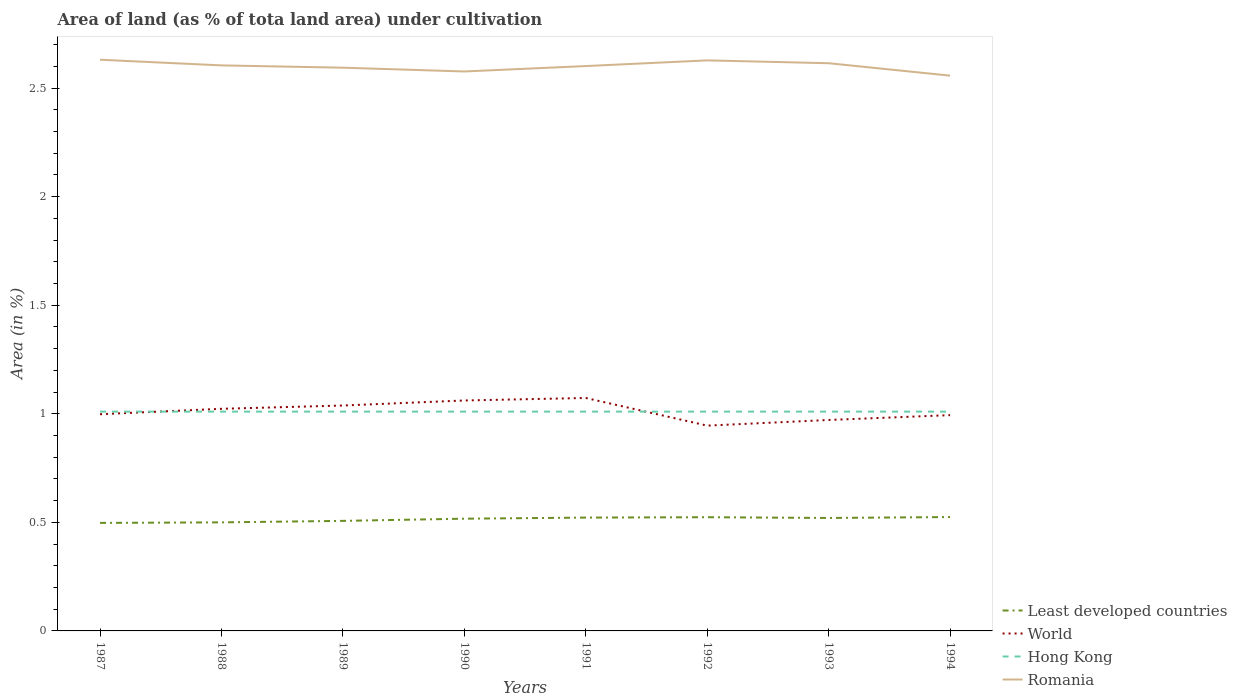Does the line corresponding to Least developed countries intersect with the line corresponding to Romania?
Provide a succinct answer. No. Across all years, what is the maximum percentage of land under cultivation in Least developed countries?
Offer a terse response. 0.5. What is the total percentage of land under cultivation in Least developed countries in the graph?
Provide a succinct answer. -0. What is the difference between the highest and the second highest percentage of land under cultivation in World?
Your response must be concise. 0.13. What is the difference between the highest and the lowest percentage of land under cultivation in Romania?
Your answer should be very brief. 5. What is the difference between two consecutive major ticks on the Y-axis?
Keep it short and to the point. 0.5. Does the graph contain grids?
Offer a very short reply. No. Where does the legend appear in the graph?
Offer a very short reply. Bottom right. How many legend labels are there?
Offer a very short reply. 4. What is the title of the graph?
Your answer should be compact. Area of land (as % of tota land area) under cultivation. What is the label or title of the Y-axis?
Ensure brevity in your answer.  Area (in %). What is the Area (in %) in Least developed countries in 1987?
Your response must be concise. 0.5. What is the Area (in %) of World in 1987?
Provide a short and direct response. 1. What is the Area (in %) of Hong Kong in 1987?
Offer a very short reply. 1.01. What is the Area (in %) in Romania in 1987?
Offer a very short reply. 2.63. What is the Area (in %) of Least developed countries in 1988?
Your answer should be very brief. 0.5. What is the Area (in %) of World in 1988?
Offer a very short reply. 1.02. What is the Area (in %) of Hong Kong in 1988?
Provide a short and direct response. 1.01. What is the Area (in %) of Romania in 1988?
Your answer should be compact. 2.6. What is the Area (in %) of Least developed countries in 1989?
Your answer should be compact. 0.51. What is the Area (in %) of World in 1989?
Provide a succinct answer. 1.04. What is the Area (in %) of Hong Kong in 1989?
Your response must be concise. 1.01. What is the Area (in %) in Romania in 1989?
Provide a short and direct response. 2.59. What is the Area (in %) in Least developed countries in 1990?
Your response must be concise. 0.52. What is the Area (in %) in World in 1990?
Your answer should be compact. 1.06. What is the Area (in %) in Hong Kong in 1990?
Make the answer very short. 1.01. What is the Area (in %) of Romania in 1990?
Ensure brevity in your answer.  2.58. What is the Area (in %) of Least developed countries in 1991?
Offer a terse response. 0.52. What is the Area (in %) of World in 1991?
Your answer should be very brief. 1.07. What is the Area (in %) in Hong Kong in 1991?
Ensure brevity in your answer.  1.01. What is the Area (in %) in Romania in 1991?
Provide a succinct answer. 2.6. What is the Area (in %) of Least developed countries in 1992?
Your response must be concise. 0.52. What is the Area (in %) of World in 1992?
Keep it short and to the point. 0.95. What is the Area (in %) of Hong Kong in 1992?
Your answer should be very brief. 1.01. What is the Area (in %) in Romania in 1992?
Your answer should be compact. 2.63. What is the Area (in %) in Least developed countries in 1993?
Offer a very short reply. 0.52. What is the Area (in %) in World in 1993?
Your response must be concise. 0.97. What is the Area (in %) in Hong Kong in 1993?
Offer a terse response. 1.01. What is the Area (in %) of Romania in 1993?
Your answer should be compact. 2.61. What is the Area (in %) in Least developed countries in 1994?
Ensure brevity in your answer.  0.52. What is the Area (in %) in World in 1994?
Make the answer very short. 0.99. What is the Area (in %) of Hong Kong in 1994?
Keep it short and to the point. 1.01. What is the Area (in %) of Romania in 1994?
Make the answer very short. 2.56. Across all years, what is the maximum Area (in %) of Least developed countries?
Provide a succinct answer. 0.52. Across all years, what is the maximum Area (in %) of World?
Ensure brevity in your answer.  1.07. Across all years, what is the maximum Area (in %) in Hong Kong?
Provide a succinct answer. 1.01. Across all years, what is the maximum Area (in %) of Romania?
Ensure brevity in your answer.  2.63. Across all years, what is the minimum Area (in %) of Least developed countries?
Your answer should be very brief. 0.5. Across all years, what is the minimum Area (in %) in World?
Provide a short and direct response. 0.95. Across all years, what is the minimum Area (in %) of Hong Kong?
Your response must be concise. 1.01. Across all years, what is the minimum Area (in %) in Romania?
Offer a very short reply. 2.56. What is the total Area (in %) of Least developed countries in the graph?
Offer a terse response. 4.11. What is the total Area (in %) in World in the graph?
Make the answer very short. 8.11. What is the total Area (in %) in Hong Kong in the graph?
Offer a very short reply. 8.08. What is the total Area (in %) of Romania in the graph?
Ensure brevity in your answer.  20.81. What is the difference between the Area (in %) of Least developed countries in 1987 and that in 1988?
Give a very brief answer. -0. What is the difference between the Area (in %) of World in 1987 and that in 1988?
Keep it short and to the point. -0.03. What is the difference between the Area (in %) of Hong Kong in 1987 and that in 1988?
Your response must be concise. 0. What is the difference between the Area (in %) in Romania in 1987 and that in 1988?
Your response must be concise. 0.03. What is the difference between the Area (in %) of Least developed countries in 1987 and that in 1989?
Give a very brief answer. -0.01. What is the difference between the Area (in %) of World in 1987 and that in 1989?
Your answer should be very brief. -0.04. What is the difference between the Area (in %) of Hong Kong in 1987 and that in 1989?
Your answer should be compact. 0. What is the difference between the Area (in %) in Romania in 1987 and that in 1989?
Ensure brevity in your answer.  0.04. What is the difference between the Area (in %) of Least developed countries in 1987 and that in 1990?
Keep it short and to the point. -0.02. What is the difference between the Area (in %) in World in 1987 and that in 1990?
Give a very brief answer. -0.06. What is the difference between the Area (in %) in Romania in 1987 and that in 1990?
Provide a succinct answer. 0.05. What is the difference between the Area (in %) in Least developed countries in 1987 and that in 1991?
Keep it short and to the point. -0.02. What is the difference between the Area (in %) in World in 1987 and that in 1991?
Ensure brevity in your answer.  -0.07. What is the difference between the Area (in %) of Romania in 1987 and that in 1991?
Give a very brief answer. 0.03. What is the difference between the Area (in %) of Least developed countries in 1987 and that in 1992?
Your answer should be very brief. -0.03. What is the difference between the Area (in %) in World in 1987 and that in 1992?
Make the answer very short. 0.05. What is the difference between the Area (in %) in Hong Kong in 1987 and that in 1992?
Provide a short and direct response. 0. What is the difference between the Area (in %) in Romania in 1987 and that in 1992?
Ensure brevity in your answer.  0. What is the difference between the Area (in %) of Least developed countries in 1987 and that in 1993?
Your answer should be compact. -0.02. What is the difference between the Area (in %) of World in 1987 and that in 1993?
Provide a short and direct response. 0.03. What is the difference between the Area (in %) of Hong Kong in 1987 and that in 1993?
Your answer should be compact. 0. What is the difference between the Area (in %) of Romania in 1987 and that in 1993?
Your response must be concise. 0.02. What is the difference between the Area (in %) in Least developed countries in 1987 and that in 1994?
Your answer should be compact. -0.03. What is the difference between the Area (in %) in World in 1987 and that in 1994?
Offer a terse response. 0. What is the difference between the Area (in %) in Romania in 1987 and that in 1994?
Your answer should be compact. 0.07. What is the difference between the Area (in %) of Least developed countries in 1988 and that in 1989?
Give a very brief answer. -0.01. What is the difference between the Area (in %) in World in 1988 and that in 1989?
Your response must be concise. -0.02. What is the difference between the Area (in %) in Romania in 1988 and that in 1989?
Your answer should be very brief. 0.01. What is the difference between the Area (in %) in Least developed countries in 1988 and that in 1990?
Offer a terse response. -0.02. What is the difference between the Area (in %) of World in 1988 and that in 1990?
Your answer should be compact. -0.04. What is the difference between the Area (in %) of Romania in 1988 and that in 1990?
Provide a succinct answer. 0.03. What is the difference between the Area (in %) in Least developed countries in 1988 and that in 1991?
Your response must be concise. -0.02. What is the difference between the Area (in %) in World in 1988 and that in 1991?
Provide a short and direct response. -0.05. What is the difference between the Area (in %) in Romania in 1988 and that in 1991?
Provide a short and direct response. 0. What is the difference between the Area (in %) in Least developed countries in 1988 and that in 1992?
Keep it short and to the point. -0.02. What is the difference between the Area (in %) of World in 1988 and that in 1992?
Make the answer very short. 0.08. What is the difference between the Area (in %) of Hong Kong in 1988 and that in 1992?
Provide a succinct answer. 0. What is the difference between the Area (in %) in Romania in 1988 and that in 1992?
Give a very brief answer. -0.02. What is the difference between the Area (in %) in Least developed countries in 1988 and that in 1993?
Your answer should be very brief. -0.02. What is the difference between the Area (in %) of World in 1988 and that in 1993?
Offer a terse response. 0.05. What is the difference between the Area (in %) in Hong Kong in 1988 and that in 1993?
Offer a terse response. 0. What is the difference between the Area (in %) of Romania in 1988 and that in 1993?
Give a very brief answer. -0.01. What is the difference between the Area (in %) in Least developed countries in 1988 and that in 1994?
Your answer should be very brief. -0.02. What is the difference between the Area (in %) in World in 1988 and that in 1994?
Offer a terse response. 0.03. What is the difference between the Area (in %) in Romania in 1988 and that in 1994?
Your response must be concise. 0.05. What is the difference between the Area (in %) in Least developed countries in 1989 and that in 1990?
Your response must be concise. -0.01. What is the difference between the Area (in %) of World in 1989 and that in 1990?
Your response must be concise. -0.02. What is the difference between the Area (in %) of Hong Kong in 1989 and that in 1990?
Ensure brevity in your answer.  0. What is the difference between the Area (in %) in Romania in 1989 and that in 1990?
Offer a very short reply. 0.02. What is the difference between the Area (in %) of Least developed countries in 1989 and that in 1991?
Your response must be concise. -0.02. What is the difference between the Area (in %) of World in 1989 and that in 1991?
Your response must be concise. -0.03. What is the difference between the Area (in %) of Romania in 1989 and that in 1991?
Your response must be concise. -0.01. What is the difference between the Area (in %) in Least developed countries in 1989 and that in 1992?
Offer a very short reply. -0.02. What is the difference between the Area (in %) in World in 1989 and that in 1992?
Your answer should be compact. 0.09. What is the difference between the Area (in %) of Hong Kong in 1989 and that in 1992?
Your answer should be very brief. 0. What is the difference between the Area (in %) in Romania in 1989 and that in 1992?
Keep it short and to the point. -0.03. What is the difference between the Area (in %) in Least developed countries in 1989 and that in 1993?
Offer a terse response. -0.01. What is the difference between the Area (in %) of World in 1989 and that in 1993?
Your response must be concise. 0.07. What is the difference between the Area (in %) in Romania in 1989 and that in 1993?
Your answer should be very brief. -0.02. What is the difference between the Area (in %) in Least developed countries in 1989 and that in 1994?
Ensure brevity in your answer.  -0.02. What is the difference between the Area (in %) in World in 1989 and that in 1994?
Provide a succinct answer. 0.04. What is the difference between the Area (in %) in Hong Kong in 1989 and that in 1994?
Your answer should be compact. 0. What is the difference between the Area (in %) in Romania in 1989 and that in 1994?
Your response must be concise. 0.04. What is the difference between the Area (in %) of Least developed countries in 1990 and that in 1991?
Your answer should be compact. -0.01. What is the difference between the Area (in %) in World in 1990 and that in 1991?
Give a very brief answer. -0.01. What is the difference between the Area (in %) of Hong Kong in 1990 and that in 1991?
Your answer should be very brief. 0. What is the difference between the Area (in %) in Romania in 1990 and that in 1991?
Your answer should be compact. -0.02. What is the difference between the Area (in %) in Least developed countries in 1990 and that in 1992?
Ensure brevity in your answer.  -0.01. What is the difference between the Area (in %) in World in 1990 and that in 1992?
Provide a short and direct response. 0.12. What is the difference between the Area (in %) of Hong Kong in 1990 and that in 1992?
Your answer should be very brief. 0. What is the difference between the Area (in %) of Romania in 1990 and that in 1992?
Make the answer very short. -0.05. What is the difference between the Area (in %) in Least developed countries in 1990 and that in 1993?
Offer a terse response. -0. What is the difference between the Area (in %) of World in 1990 and that in 1993?
Provide a succinct answer. 0.09. What is the difference between the Area (in %) of Romania in 1990 and that in 1993?
Keep it short and to the point. -0.04. What is the difference between the Area (in %) in Least developed countries in 1990 and that in 1994?
Provide a short and direct response. -0.01. What is the difference between the Area (in %) in World in 1990 and that in 1994?
Your answer should be very brief. 0.07. What is the difference between the Area (in %) of Romania in 1990 and that in 1994?
Your response must be concise. 0.02. What is the difference between the Area (in %) of Least developed countries in 1991 and that in 1992?
Make the answer very short. -0. What is the difference between the Area (in %) in World in 1991 and that in 1992?
Give a very brief answer. 0.13. What is the difference between the Area (in %) in Hong Kong in 1991 and that in 1992?
Your answer should be compact. 0. What is the difference between the Area (in %) of Romania in 1991 and that in 1992?
Your answer should be very brief. -0.03. What is the difference between the Area (in %) of Least developed countries in 1991 and that in 1993?
Make the answer very short. 0. What is the difference between the Area (in %) of World in 1991 and that in 1993?
Offer a terse response. 0.1. What is the difference between the Area (in %) of Hong Kong in 1991 and that in 1993?
Provide a short and direct response. 0. What is the difference between the Area (in %) of Romania in 1991 and that in 1993?
Provide a short and direct response. -0.01. What is the difference between the Area (in %) of Least developed countries in 1991 and that in 1994?
Offer a terse response. -0. What is the difference between the Area (in %) of World in 1991 and that in 1994?
Make the answer very short. 0.08. What is the difference between the Area (in %) in Hong Kong in 1991 and that in 1994?
Provide a short and direct response. 0. What is the difference between the Area (in %) in Romania in 1991 and that in 1994?
Provide a short and direct response. 0.04. What is the difference between the Area (in %) of Least developed countries in 1992 and that in 1993?
Provide a succinct answer. 0. What is the difference between the Area (in %) in World in 1992 and that in 1993?
Give a very brief answer. -0.03. What is the difference between the Area (in %) of Romania in 1992 and that in 1993?
Provide a succinct answer. 0.01. What is the difference between the Area (in %) of Least developed countries in 1992 and that in 1994?
Your response must be concise. -0. What is the difference between the Area (in %) of World in 1992 and that in 1994?
Your response must be concise. -0.05. What is the difference between the Area (in %) in Romania in 1992 and that in 1994?
Provide a short and direct response. 0.07. What is the difference between the Area (in %) in Least developed countries in 1993 and that in 1994?
Offer a very short reply. -0. What is the difference between the Area (in %) of World in 1993 and that in 1994?
Your answer should be compact. -0.02. What is the difference between the Area (in %) in Romania in 1993 and that in 1994?
Your answer should be very brief. 0.06. What is the difference between the Area (in %) in Least developed countries in 1987 and the Area (in %) in World in 1988?
Ensure brevity in your answer.  -0.53. What is the difference between the Area (in %) in Least developed countries in 1987 and the Area (in %) in Hong Kong in 1988?
Provide a succinct answer. -0.51. What is the difference between the Area (in %) of Least developed countries in 1987 and the Area (in %) of Romania in 1988?
Give a very brief answer. -2.11. What is the difference between the Area (in %) of World in 1987 and the Area (in %) of Hong Kong in 1988?
Keep it short and to the point. -0.01. What is the difference between the Area (in %) of World in 1987 and the Area (in %) of Romania in 1988?
Your answer should be very brief. -1.61. What is the difference between the Area (in %) of Hong Kong in 1987 and the Area (in %) of Romania in 1988?
Your answer should be very brief. -1.59. What is the difference between the Area (in %) of Least developed countries in 1987 and the Area (in %) of World in 1989?
Give a very brief answer. -0.54. What is the difference between the Area (in %) in Least developed countries in 1987 and the Area (in %) in Hong Kong in 1989?
Your response must be concise. -0.51. What is the difference between the Area (in %) of Least developed countries in 1987 and the Area (in %) of Romania in 1989?
Make the answer very short. -2.1. What is the difference between the Area (in %) of World in 1987 and the Area (in %) of Hong Kong in 1989?
Ensure brevity in your answer.  -0.01. What is the difference between the Area (in %) in World in 1987 and the Area (in %) in Romania in 1989?
Give a very brief answer. -1.6. What is the difference between the Area (in %) in Hong Kong in 1987 and the Area (in %) in Romania in 1989?
Provide a succinct answer. -1.58. What is the difference between the Area (in %) of Least developed countries in 1987 and the Area (in %) of World in 1990?
Offer a very short reply. -0.56. What is the difference between the Area (in %) of Least developed countries in 1987 and the Area (in %) of Hong Kong in 1990?
Your response must be concise. -0.51. What is the difference between the Area (in %) in Least developed countries in 1987 and the Area (in %) in Romania in 1990?
Provide a succinct answer. -2.08. What is the difference between the Area (in %) in World in 1987 and the Area (in %) in Hong Kong in 1990?
Offer a very short reply. -0.01. What is the difference between the Area (in %) in World in 1987 and the Area (in %) in Romania in 1990?
Keep it short and to the point. -1.58. What is the difference between the Area (in %) of Hong Kong in 1987 and the Area (in %) of Romania in 1990?
Provide a short and direct response. -1.57. What is the difference between the Area (in %) in Least developed countries in 1987 and the Area (in %) in World in 1991?
Offer a very short reply. -0.58. What is the difference between the Area (in %) in Least developed countries in 1987 and the Area (in %) in Hong Kong in 1991?
Give a very brief answer. -0.51. What is the difference between the Area (in %) in Least developed countries in 1987 and the Area (in %) in Romania in 1991?
Your answer should be very brief. -2.1. What is the difference between the Area (in %) in World in 1987 and the Area (in %) in Hong Kong in 1991?
Give a very brief answer. -0.01. What is the difference between the Area (in %) of World in 1987 and the Area (in %) of Romania in 1991?
Offer a terse response. -1.6. What is the difference between the Area (in %) in Hong Kong in 1987 and the Area (in %) in Romania in 1991?
Offer a very short reply. -1.59. What is the difference between the Area (in %) in Least developed countries in 1987 and the Area (in %) in World in 1992?
Provide a succinct answer. -0.45. What is the difference between the Area (in %) of Least developed countries in 1987 and the Area (in %) of Hong Kong in 1992?
Offer a terse response. -0.51. What is the difference between the Area (in %) of Least developed countries in 1987 and the Area (in %) of Romania in 1992?
Your response must be concise. -2.13. What is the difference between the Area (in %) of World in 1987 and the Area (in %) of Hong Kong in 1992?
Provide a succinct answer. -0.01. What is the difference between the Area (in %) in World in 1987 and the Area (in %) in Romania in 1992?
Ensure brevity in your answer.  -1.63. What is the difference between the Area (in %) in Hong Kong in 1987 and the Area (in %) in Romania in 1992?
Offer a very short reply. -1.62. What is the difference between the Area (in %) in Least developed countries in 1987 and the Area (in %) in World in 1993?
Offer a very short reply. -0.47. What is the difference between the Area (in %) of Least developed countries in 1987 and the Area (in %) of Hong Kong in 1993?
Your response must be concise. -0.51. What is the difference between the Area (in %) in Least developed countries in 1987 and the Area (in %) in Romania in 1993?
Provide a short and direct response. -2.12. What is the difference between the Area (in %) in World in 1987 and the Area (in %) in Hong Kong in 1993?
Ensure brevity in your answer.  -0.01. What is the difference between the Area (in %) of World in 1987 and the Area (in %) of Romania in 1993?
Give a very brief answer. -1.62. What is the difference between the Area (in %) of Hong Kong in 1987 and the Area (in %) of Romania in 1993?
Ensure brevity in your answer.  -1.6. What is the difference between the Area (in %) in Least developed countries in 1987 and the Area (in %) in World in 1994?
Your response must be concise. -0.5. What is the difference between the Area (in %) in Least developed countries in 1987 and the Area (in %) in Hong Kong in 1994?
Ensure brevity in your answer.  -0.51. What is the difference between the Area (in %) of Least developed countries in 1987 and the Area (in %) of Romania in 1994?
Ensure brevity in your answer.  -2.06. What is the difference between the Area (in %) in World in 1987 and the Area (in %) in Hong Kong in 1994?
Offer a very short reply. -0.01. What is the difference between the Area (in %) of World in 1987 and the Area (in %) of Romania in 1994?
Your response must be concise. -1.56. What is the difference between the Area (in %) of Hong Kong in 1987 and the Area (in %) of Romania in 1994?
Give a very brief answer. -1.55. What is the difference between the Area (in %) of Least developed countries in 1988 and the Area (in %) of World in 1989?
Provide a short and direct response. -0.54. What is the difference between the Area (in %) in Least developed countries in 1988 and the Area (in %) in Hong Kong in 1989?
Provide a succinct answer. -0.51. What is the difference between the Area (in %) in Least developed countries in 1988 and the Area (in %) in Romania in 1989?
Make the answer very short. -2.09. What is the difference between the Area (in %) of World in 1988 and the Area (in %) of Hong Kong in 1989?
Provide a short and direct response. 0.01. What is the difference between the Area (in %) in World in 1988 and the Area (in %) in Romania in 1989?
Make the answer very short. -1.57. What is the difference between the Area (in %) of Hong Kong in 1988 and the Area (in %) of Romania in 1989?
Your answer should be compact. -1.58. What is the difference between the Area (in %) of Least developed countries in 1988 and the Area (in %) of World in 1990?
Your answer should be compact. -0.56. What is the difference between the Area (in %) of Least developed countries in 1988 and the Area (in %) of Hong Kong in 1990?
Offer a terse response. -0.51. What is the difference between the Area (in %) of Least developed countries in 1988 and the Area (in %) of Romania in 1990?
Keep it short and to the point. -2.08. What is the difference between the Area (in %) in World in 1988 and the Area (in %) in Hong Kong in 1990?
Provide a succinct answer. 0.01. What is the difference between the Area (in %) in World in 1988 and the Area (in %) in Romania in 1990?
Make the answer very short. -1.55. What is the difference between the Area (in %) of Hong Kong in 1988 and the Area (in %) of Romania in 1990?
Your response must be concise. -1.57. What is the difference between the Area (in %) of Least developed countries in 1988 and the Area (in %) of World in 1991?
Make the answer very short. -0.57. What is the difference between the Area (in %) in Least developed countries in 1988 and the Area (in %) in Hong Kong in 1991?
Give a very brief answer. -0.51. What is the difference between the Area (in %) in Least developed countries in 1988 and the Area (in %) in Romania in 1991?
Keep it short and to the point. -2.1. What is the difference between the Area (in %) in World in 1988 and the Area (in %) in Hong Kong in 1991?
Your response must be concise. 0.01. What is the difference between the Area (in %) of World in 1988 and the Area (in %) of Romania in 1991?
Provide a short and direct response. -1.58. What is the difference between the Area (in %) of Hong Kong in 1988 and the Area (in %) of Romania in 1991?
Your answer should be very brief. -1.59. What is the difference between the Area (in %) of Least developed countries in 1988 and the Area (in %) of World in 1992?
Provide a short and direct response. -0.45. What is the difference between the Area (in %) of Least developed countries in 1988 and the Area (in %) of Hong Kong in 1992?
Offer a very short reply. -0.51. What is the difference between the Area (in %) in Least developed countries in 1988 and the Area (in %) in Romania in 1992?
Offer a very short reply. -2.13. What is the difference between the Area (in %) in World in 1988 and the Area (in %) in Hong Kong in 1992?
Your answer should be very brief. 0.01. What is the difference between the Area (in %) in World in 1988 and the Area (in %) in Romania in 1992?
Your answer should be very brief. -1.6. What is the difference between the Area (in %) of Hong Kong in 1988 and the Area (in %) of Romania in 1992?
Keep it short and to the point. -1.62. What is the difference between the Area (in %) in Least developed countries in 1988 and the Area (in %) in World in 1993?
Offer a terse response. -0.47. What is the difference between the Area (in %) of Least developed countries in 1988 and the Area (in %) of Hong Kong in 1993?
Make the answer very short. -0.51. What is the difference between the Area (in %) in Least developed countries in 1988 and the Area (in %) in Romania in 1993?
Make the answer very short. -2.11. What is the difference between the Area (in %) in World in 1988 and the Area (in %) in Hong Kong in 1993?
Your answer should be compact. 0.01. What is the difference between the Area (in %) of World in 1988 and the Area (in %) of Romania in 1993?
Offer a terse response. -1.59. What is the difference between the Area (in %) in Hong Kong in 1988 and the Area (in %) in Romania in 1993?
Provide a succinct answer. -1.6. What is the difference between the Area (in %) of Least developed countries in 1988 and the Area (in %) of World in 1994?
Keep it short and to the point. -0.49. What is the difference between the Area (in %) in Least developed countries in 1988 and the Area (in %) in Hong Kong in 1994?
Your answer should be compact. -0.51. What is the difference between the Area (in %) of Least developed countries in 1988 and the Area (in %) of Romania in 1994?
Provide a succinct answer. -2.06. What is the difference between the Area (in %) in World in 1988 and the Area (in %) in Hong Kong in 1994?
Your answer should be very brief. 0.01. What is the difference between the Area (in %) of World in 1988 and the Area (in %) of Romania in 1994?
Your response must be concise. -1.53. What is the difference between the Area (in %) in Hong Kong in 1988 and the Area (in %) in Romania in 1994?
Give a very brief answer. -1.55. What is the difference between the Area (in %) in Least developed countries in 1989 and the Area (in %) in World in 1990?
Your response must be concise. -0.55. What is the difference between the Area (in %) in Least developed countries in 1989 and the Area (in %) in Hong Kong in 1990?
Provide a short and direct response. -0.5. What is the difference between the Area (in %) in Least developed countries in 1989 and the Area (in %) in Romania in 1990?
Keep it short and to the point. -2.07. What is the difference between the Area (in %) of World in 1989 and the Area (in %) of Hong Kong in 1990?
Provide a short and direct response. 0.03. What is the difference between the Area (in %) in World in 1989 and the Area (in %) in Romania in 1990?
Provide a succinct answer. -1.54. What is the difference between the Area (in %) of Hong Kong in 1989 and the Area (in %) of Romania in 1990?
Make the answer very short. -1.57. What is the difference between the Area (in %) of Least developed countries in 1989 and the Area (in %) of World in 1991?
Give a very brief answer. -0.57. What is the difference between the Area (in %) of Least developed countries in 1989 and the Area (in %) of Hong Kong in 1991?
Ensure brevity in your answer.  -0.5. What is the difference between the Area (in %) in Least developed countries in 1989 and the Area (in %) in Romania in 1991?
Ensure brevity in your answer.  -2.09. What is the difference between the Area (in %) in World in 1989 and the Area (in %) in Hong Kong in 1991?
Your response must be concise. 0.03. What is the difference between the Area (in %) of World in 1989 and the Area (in %) of Romania in 1991?
Make the answer very short. -1.56. What is the difference between the Area (in %) in Hong Kong in 1989 and the Area (in %) in Romania in 1991?
Make the answer very short. -1.59. What is the difference between the Area (in %) in Least developed countries in 1989 and the Area (in %) in World in 1992?
Provide a succinct answer. -0.44. What is the difference between the Area (in %) of Least developed countries in 1989 and the Area (in %) of Hong Kong in 1992?
Offer a terse response. -0.5. What is the difference between the Area (in %) in Least developed countries in 1989 and the Area (in %) in Romania in 1992?
Provide a succinct answer. -2.12. What is the difference between the Area (in %) of World in 1989 and the Area (in %) of Hong Kong in 1992?
Offer a terse response. 0.03. What is the difference between the Area (in %) of World in 1989 and the Area (in %) of Romania in 1992?
Make the answer very short. -1.59. What is the difference between the Area (in %) in Hong Kong in 1989 and the Area (in %) in Romania in 1992?
Your answer should be compact. -1.62. What is the difference between the Area (in %) of Least developed countries in 1989 and the Area (in %) of World in 1993?
Offer a very short reply. -0.46. What is the difference between the Area (in %) in Least developed countries in 1989 and the Area (in %) in Hong Kong in 1993?
Provide a succinct answer. -0.5. What is the difference between the Area (in %) of Least developed countries in 1989 and the Area (in %) of Romania in 1993?
Your answer should be very brief. -2.11. What is the difference between the Area (in %) in World in 1989 and the Area (in %) in Hong Kong in 1993?
Provide a short and direct response. 0.03. What is the difference between the Area (in %) of World in 1989 and the Area (in %) of Romania in 1993?
Offer a terse response. -1.58. What is the difference between the Area (in %) of Hong Kong in 1989 and the Area (in %) of Romania in 1993?
Your response must be concise. -1.6. What is the difference between the Area (in %) in Least developed countries in 1989 and the Area (in %) in World in 1994?
Make the answer very short. -0.49. What is the difference between the Area (in %) in Least developed countries in 1989 and the Area (in %) in Hong Kong in 1994?
Ensure brevity in your answer.  -0.5. What is the difference between the Area (in %) of Least developed countries in 1989 and the Area (in %) of Romania in 1994?
Provide a short and direct response. -2.05. What is the difference between the Area (in %) of World in 1989 and the Area (in %) of Hong Kong in 1994?
Give a very brief answer. 0.03. What is the difference between the Area (in %) in World in 1989 and the Area (in %) in Romania in 1994?
Offer a terse response. -1.52. What is the difference between the Area (in %) in Hong Kong in 1989 and the Area (in %) in Romania in 1994?
Provide a short and direct response. -1.55. What is the difference between the Area (in %) of Least developed countries in 1990 and the Area (in %) of World in 1991?
Provide a short and direct response. -0.56. What is the difference between the Area (in %) of Least developed countries in 1990 and the Area (in %) of Hong Kong in 1991?
Your answer should be very brief. -0.49. What is the difference between the Area (in %) in Least developed countries in 1990 and the Area (in %) in Romania in 1991?
Your answer should be very brief. -2.08. What is the difference between the Area (in %) of World in 1990 and the Area (in %) of Hong Kong in 1991?
Provide a short and direct response. 0.05. What is the difference between the Area (in %) in World in 1990 and the Area (in %) in Romania in 1991?
Give a very brief answer. -1.54. What is the difference between the Area (in %) of Hong Kong in 1990 and the Area (in %) of Romania in 1991?
Offer a very short reply. -1.59. What is the difference between the Area (in %) in Least developed countries in 1990 and the Area (in %) in World in 1992?
Make the answer very short. -0.43. What is the difference between the Area (in %) of Least developed countries in 1990 and the Area (in %) of Hong Kong in 1992?
Make the answer very short. -0.49. What is the difference between the Area (in %) in Least developed countries in 1990 and the Area (in %) in Romania in 1992?
Offer a terse response. -2.11. What is the difference between the Area (in %) of World in 1990 and the Area (in %) of Hong Kong in 1992?
Ensure brevity in your answer.  0.05. What is the difference between the Area (in %) of World in 1990 and the Area (in %) of Romania in 1992?
Your answer should be very brief. -1.57. What is the difference between the Area (in %) in Hong Kong in 1990 and the Area (in %) in Romania in 1992?
Provide a short and direct response. -1.62. What is the difference between the Area (in %) in Least developed countries in 1990 and the Area (in %) in World in 1993?
Make the answer very short. -0.45. What is the difference between the Area (in %) in Least developed countries in 1990 and the Area (in %) in Hong Kong in 1993?
Keep it short and to the point. -0.49. What is the difference between the Area (in %) of Least developed countries in 1990 and the Area (in %) of Romania in 1993?
Keep it short and to the point. -2.1. What is the difference between the Area (in %) in World in 1990 and the Area (in %) in Hong Kong in 1993?
Your answer should be very brief. 0.05. What is the difference between the Area (in %) of World in 1990 and the Area (in %) of Romania in 1993?
Provide a short and direct response. -1.55. What is the difference between the Area (in %) of Hong Kong in 1990 and the Area (in %) of Romania in 1993?
Your answer should be very brief. -1.6. What is the difference between the Area (in %) in Least developed countries in 1990 and the Area (in %) in World in 1994?
Offer a terse response. -0.48. What is the difference between the Area (in %) in Least developed countries in 1990 and the Area (in %) in Hong Kong in 1994?
Keep it short and to the point. -0.49. What is the difference between the Area (in %) of Least developed countries in 1990 and the Area (in %) of Romania in 1994?
Offer a very short reply. -2.04. What is the difference between the Area (in %) in World in 1990 and the Area (in %) in Hong Kong in 1994?
Make the answer very short. 0.05. What is the difference between the Area (in %) in World in 1990 and the Area (in %) in Romania in 1994?
Provide a short and direct response. -1.5. What is the difference between the Area (in %) of Hong Kong in 1990 and the Area (in %) of Romania in 1994?
Your response must be concise. -1.55. What is the difference between the Area (in %) in Least developed countries in 1991 and the Area (in %) in World in 1992?
Offer a terse response. -0.42. What is the difference between the Area (in %) of Least developed countries in 1991 and the Area (in %) of Hong Kong in 1992?
Ensure brevity in your answer.  -0.49. What is the difference between the Area (in %) in Least developed countries in 1991 and the Area (in %) in Romania in 1992?
Offer a terse response. -2.11. What is the difference between the Area (in %) of World in 1991 and the Area (in %) of Hong Kong in 1992?
Your answer should be very brief. 0.06. What is the difference between the Area (in %) of World in 1991 and the Area (in %) of Romania in 1992?
Your answer should be compact. -1.55. What is the difference between the Area (in %) in Hong Kong in 1991 and the Area (in %) in Romania in 1992?
Make the answer very short. -1.62. What is the difference between the Area (in %) in Least developed countries in 1991 and the Area (in %) in World in 1993?
Make the answer very short. -0.45. What is the difference between the Area (in %) in Least developed countries in 1991 and the Area (in %) in Hong Kong in 1993?
Keep it short and to the point. -0.49. What is the difference between the Area (in %) in Least developed countries in 1991 and the Area (in %) in Romania in 1993?
Your answer should be compact. -2.09. What is the difference between the Area (in %) in World in 1991 and the Area (in %) in Hong Kong in 1993?
Offer a very short reply. 0.06. What is the difference between the Area (in %) in World in 1991 and the Area (in %) in Romania in 1993?
Your answer should be very brief. -1.54. What is the difference between the Area (in %) of Hong Kong in 1991 and the Area (in %) of Romania in 1993?
Provide a succinct answer. -1.6. What is the difference between the Area (in %) of Least developed countries in 1991 and the Area (in %) of World in 1994?
Your answer should be compact. -0.47. What is the difference between the Area (in %) of Least developed countries in 1991 and the Area (in %) of Hong Kong in 1994?
Ensure brevity in your answer.  -0.49. What is the difference between the Area (in %) of Least developed countries in 1991 and the Area (in %) of Romania in 1994?
Give a very brief answer. -2.04. What is the difference between the Area (in %) of World in 1991 and the Area (in %) of Hong Kong in 1994?
Ensure brevity in your answer.  0.06. What is the difference between the Area (in %) in World in 1991 and the Area (in %) in Romania in 1994?
Give a very brief answer. -1.48. What is the difference between the Area (in %) in Hong Kong in 1991 and the Area (in %) in Romania in 1994?
Offer a very short reply. -1.55. What is the difference between the Area (in %) of Least developed countries in 1992 and the Area (in %) of World in 1993?
Ensure brevity in your answer.  -0.45. What is the difference between the Area (in %) in Least developed countries in 1992 and the Area (in %) in Hong Kong in 1993?
Ensure brevity in your answer.  -0.49. What is the difference between the Area (in %) in Least developed countries in 1992 and the Area (in %) in Romania in 1993?
Your response must be concise. -2.09. What is the difference between the Area (in %) of World in 1992 and the Area (in %) of Hong Kong in 1993?
Your answer should be compact. -0.06. What is the difference between the Area (in %) in World in 1992 and the Area (in %) in Romania in 1993?
Give a very brief answer. -1.67. What is the difference between the Area (in %) in Hong Kong in 1992 and the Area (in %) in Romania in 1993?
Your answer should be compact. -1.6. What is the difference between the Area (in %) of Least developed countries in 1992 and the Area (in %) of World in 1994?
Ensure brevity in your answer.  -0.47. What is the difference between the Area (in %) of Least developed countries in 1992 and the Area (in %) of Hong Kong in 1994?
Your response must be concise. -0.49. What is the difference between the Area (in %) of Least developed countries in 1992 and the Area (in %) of Romania in 1994?
Make the answer very short. -2.03. What is the difference between the Area (in %) in World in 1992 and the Area (in %) in Hong Kong in 1994?
Your answer should be compact. -0.06. What is the difference between the Area (in %) in World in 1992 and the Area (in %) in Romania in 1994?
Offer a terse response. -1.61. What is the difference between the Area (in %) of Hong Kong in 1992 and the Area (in %) of Romania in 1994?
Offer a terse response. -1.55. What is the difference between the Area (in %) of Least developed countries in 1993 and the Area (in %) of World in 1994?
Ensure brevity in your answer.  -0.47. What is the difference between the Area (in %) in Least developed countries in 1993 and the Area (in %) in Hong Kong in 1994?
Offer a terse response. -0.49. What is the difference between the Area (in %) in Least developed countries in 1993 and the Area (in %) in Romania in 1994?
Make the answer very short. -2.04. What is the difference between the Area (in %) in World in 1993 and the Area (in %) in Hong Kong in 1994?
Your answer should be very brief. -0.04. What is the difference between the Area (in %) of World in 1993 and the Area (in %) of Romania in 1994?
Ensure brevity in your answer.  -1.59. What is the difference between the Area (in %) of Hong Kong in 1993 and the Area (in %) of Romania in 1994?
Offer a terse response. -1.55. What is the average Area (in %) of Least developed countries per year?
Your answer should be compact. 0.51. What is the average Area (in %) of World per year?
Offer a terse response. 1.01. What is the average Area (in %) in Hong Kong per year?
Your answer should be very brief. 1.01. What is the average Area (in %) of Romania per year?
Keep it short and to the point. 2.6. In the year 1987, what is the difference between the Area (in %) of Least developed countries and Area (in %) of World?
Ensure brevity in your answer.  -0.5. In the year 1987, what is the difference between the Area (in %) of Least developed countries and Area (in %) of Hong Kong?
Your response must be concise. -0.51. In the year 1987, what is the difference between the Area (in %) of Least developed countries and Area (in %) of Romania?
Give a very brief answer. -2.13. In the year 1987, what is the difference between the Area (in %) in World and Area (in %) in Hong Kong?
Give a very brief answer. -0.01. In the year 1987, what is the difference between the Area (in %) of World and Area (in %) of Romania?
Your response must be concise. -1.63. In the year 1987, what is the difference between the Area (in %) in Hong Kong and Area (in %) in Romania?
Provide a succinct answer. -1.62. In the year 1988, what is the difference between the Area (in %) in Least developed countries and Area (in %) in World?
Offer a terse response. -0.52. In the year 1988, what is the difference between the Area (in %) of Least developed countries and Area (in %) of Hong Kong?
Provide a short and direct response. -0.51. In the year 1988, what is the difference between the Area (in %) in Least developed countries and Area (in %) in Romania?
Make the answer very short. -2.1. In the year 1988, what is the difference between the Area (in %) of World and Area (in %) of Hong Kong?
Keep it short and to the point. 0.01. In the year 1988, what is the difference between the Area (in %) in World and Area (in %) in Romania?
Your answer should be compact. -1.58. In the year 1988, what is the difference between the Area (in %) of Hong Kong and Area (in %) of Romania?
Your answer should be compact. -1.59. In the year 1989, what is the difference between the Area (in %) in Least developed countries and Area (in %) in World?
Your answer should be very brief. -0.53. In the year 1989, what is the difference between the Area (in %) in Least developed countries and Area (in %) in Hong Kong?
Make the answer very short. -0.5. In the year 1989, what is the difference between the Area (in %) of Least developed countries and Area (in %) of Romania?
Offer a terse response. -2.09. In the year 1989, what is the difference between the Area (in %) in World and Area (in %) in Hong Kong?
Your answer should be compact. 0.03. In the year 1989, what is the difference between the Area (in %) in World and Area (in %) in Romania?
Provide a succinct answer. -1.56. In the year 1989, what is the difference between the Area (in %) of Hong Kong and Area (in %) of Romania?
Keep it short and to the point. -1.58. In the year 1990, what is the difference between the Area (in %) in Least developed countries and Area (in %) in World?
Keep it short and to the point. -0.54. In the year 1990, what is the difference between the Area (in %) in Least developed countries and Area (in %) in Hong Kong?
Ensure brevity in your answer.  -0.49. In the year 1990, what is the difference between the Area (in %) of Least developed countries and Area (in %) of Romania?
Offer a very short reply. -2.06. In the year 1990, what is the difference between the Area (in %) in World and Area (in %) in Hong Kong?
Provide a succinct answer. 0.05. In the year 1990, what is the difference between the Area (in %) of World and Area (in %) of Romania?
Make the answer very short. -1.52. In the year 1990, what is the difference between the Area (in %) of Hong Kong and Area (in %) of Romania?
Your answer should be compact. -1.57. In the year 1991, what is the difference between the Area (in %) in Least developed countries and Area (in %) in World?
Your answer should be very brief. -0.55. In the year 1991, what is the difference between the Area (in %) of Least developed countries and Area (in %) of Hong Kong?
Provide a succinct answer. -0.49. In the year 1991, what is the difference between the Area (in %) in Least developed countries and Area (in %) in Romania?
Make the answer very short. -2.08. In the year 1991, what is the difference between the Area (in %) of World and Area (in %) of Hong Kong?
Provide a succinct answer. 0.06. In the year 1991, what is the difference between the Area (in %) in World and Area (in %) in Romania?
Offer a very short reply. -1.53. In the year 1991, what is the difference between the Area (in %) in Hong Kong and Area (in %) in Romania?
Keep it short and to the point. -1.59. In the year 1992, what is the difference between the Area (in %) in Least developed countries and Area (in %) in World?
Your answer should be compact. -0.42. In the year 1992, what is the difference between the Area (in %) in Least developed countries and Area (in %) in Hong Kong?
Your response must be concise. -0.49. In the year 1992, what is the difference between the Area (in %) in Least developed countries and Area (in %) in Romania?
Make the answer very short. -2.1. In the year 1992, what is the difference between the Area (in %) in World and Area (in %) in Hong Kong?
Your answer should be compact. -0.06. In the year 1992, what is the difference between the Area (in %) of World and Area (in %) of Romania?
Your answer should be compact. -1.68. In the year 1992, what is the difference between the Area (in %) of Hong Kong and Area (in %) of Romania?
Ensure brevity in your answer.  -1.62. In the year 1993, what is the difference between the Area (in %) in Least developed countries and Area (in %) in World?
Ensure brevity in your answer.  -0.45. In the year 1993, what is the difference between the Area (in %) of Least developed countries and Area (in %) of Hong Kong?
Offer a terse response. -0.49. In the year 1993, what is the difference between the Area (in %) of Least developed countries and Area (in %) of Romania?
Provide a short and direct response. -2.09. In the year 1993, what is the difference between the Area (in %) of World and Area (in %) of Hong Kong?
Keep it short and to the point. -0.04. In the year 1993, what is the difference between the Area (in %) of World and Area (in %) of Romania?
Provide a short and direct response. -1.64. In the year 1993, what is the difference between the Area (in %) of Hong Kong and Area (in %) of Romania?
Offer a terse response. -1.6. In the year 1994, what is the difference between the Area (in %) of Least developed countries and Area (in %) of World?
Your response must be concise. -0.47. In the year 1994, what is the difference between the Area (in %) of Least developed countries and Area (in %) of Hong Kong?
Keep it short and to the point. -0.49. In the year 1994, what is the difference between the Area (in %) in Least developed countries and Area (in %) in Romania?
Provide a short and direct response. -2.03. In the year 1994, what is the difference between the Area (in %) of World and Area (in %) of Hong Kong?
Provide a short and direct response. -0.02. In the year 1994, what is the difference between the Area (in %) in World and Area (in %) in Romania?
Offer a very short reply. -1.56. In the year 1994, what is the difference between the Area (in %) in Hong Kong and Area (in %) in Romania?
Your answer should be very brief. -1.55. What is the ratio of the Area (in %) in World in 1987 to that in 1988?
Provide a short and direct response. 0.98. What is the ratio of the Area (in %) of Least developed countries in 1987 to that in 1989?
Keep it short and to the point. 0.98. What is the ratio of the Area (in %) in World in 1987 to that in 1989?
Offer a terse response. 0.96. What is the ratio of the Area (in %) in Romania in 1987 to that in 1989?
Ensure brevity in your answer.  1.01. What is the ratio of the Area (in %) in Least developed countries in 1987 to that in 1990?
Provide a short and direct response. 0.96. What is the ratio of the Area (in %) in World in 1987 to that in 1990?
Your answer should be compact. 0.94. What is the ratio of the Area (in %) in Hong Kong in 1987 to that in 1990?
Give a very brief answer. 1. What is the ratio of the Area (in %) of Romania in 1987 to that in 1990?
Ensure brevity in your answer.  1.02. What is the ratio of the Area (in %) in Least developed countries in 1987 to that in 1991?
Keep it short and to the point. 0.95. What is the ratio of the Area (in %) in World in 1987 to that in 1991?
Your answer should be compact. 0.93. What is the ratio of the Area (in %) in Romania in 1987 to that in 1991?
Offer a terse response. 1.01. What is the ratio of the Area (in %) in World in 1987 to that in 1992?
Offer a very short reply. 1.06. What is the ratio of the Area (in %) of Hong Kong in 1987 to that in 1992?
Provide a succinct answer. 1. What is the ratio of the Area (in %) of Least developed countries in 1987 to that in 1993?
Your answer should be very brief. 0.96. What is the ratio of the Area (in %) of World in 1987 to that in 1993?
Your answer should be compact. 1.03. What is the ratio of the Area (in %) in Romania in 1987 to that in 1993?
Provide a short and direct response. 1.01. What is the ratio of the Area (in %) in Least developed countries in 1987 to that in 1994?
Offer a terse response. 0.95. What is the ratio of the Area (in %) in World in 1987 to that in 1994?
Your answer should be compact. 1. What is the ratio of the Area (in %) of Romania in 1987 to that in 1994?
Keep it short and to the point. 1.03. What is the ratio of the Area (in %) of Least developed countries in 1988 to that in 1989?
Give a very brief answer. 0.99. What is the ratio of the Area (in %) in World in 1988 to that in 1989?
Offer a terse response. 0.99. What is the ratio of the Area (in %) of Hong Kong in 1988 to that in 1989?
Keep it short and to the point. 1. What is the ratio of the Area (in %) of Least developed countries in 1988 to that in 1990?
Offer a terse response. 0.97. What is the ratio of the Area (in %) in World in 1988 to that in 1990?
Give a very brief answer. 0.96. What is the ratio of the Area (in %) in Romania in 1988 to that in 1990?
Give a very brief answer. 1.01. What is the ratio of the Area (in %) of Least developed countries in 1988 to that in 1991?
Give a very brief answer. 0.96. What is the ratio of the Area (in %) in World in 1988 to that in 1991?
Provide a succinct answer. 0.95. What is the ratio of the Area (in %) in Hong Kong in 1988 to that in 1991?
Keep it short and to the point. 1. What is the ratio of the Area (in %) in Least developed countries in 1988 to that in 1992?
Give a very brief answer. 0.95. What is the ratio of the Area (in %) in World in 1988 to that in 1992?
Give a very brief answer. 1.08. What is the ratio of the Area (in %) in Least developed countries in 1988 to that in 1993?
Make the answer very short. 0.96. What is the ratio of the Area (in %) of World in 1988 to that in 1993?
Give a very brief answer. 1.05. What is the ratio of the Area (in %) of Hong Kong in 1988 to that in 1993?
Ensure brevity in your answer.  1. What is the ratio of the Area (in %) in Romania in 1988 to that in 1993?
Offer a terse response. 1. What is the ratio of the Area (in %) of Least developed countries in 1988 to that in 1994?
Provide a short and direct response. 0.95. What is the ratio of the Area (in %) of World in 1988 to that in 1994?
Your answer should be very brief. 1.03. What is the ratio of the Area (in %) of Hong Kong in 1988 to that in 1994?
Offer a very short reply. 1. What is the ratio of the Area (in %) of Romania in 1988 to that in 1994?
Give a very brief answer. 1.02. What is the ratio of the Area (in %) of Least developed countries in 1989 to that in 1990?
Your response must be concise. 0.98. What is the ratio of the Area (in %) in World in 1989 to that in 1990?
Provide a short and direct response. 0.98. What is the ratio of the Area (in %) of Romania in 1989 to that in 1990?
Offer a terse response. 1.01. What is the ratio of the Area (in %) in World in 1989 to that in 1991?
Offer a very short reply. 0.97. What is the ratio of the Area (in %) of Romania in 1989 to that in 1991?
Your answer should be very brief. 1. What is the ratio of the Area (in %) in Least developed countries in 1989 to that in 1992?
Ensure brevity in your answer.  0.97. What is the ratio of the Area (in %) in World in 1989 to that in 1992?
Your answer should be compact. 1.1. What is the ratio of the Area (in %) in Romania in 1989 to that in 1992?
Provide a succinct answer. 0.99. What is the ratio of the Area (in %) in Least developed countries in 1989 to that in 1993?
Your answer should be very brief. 0.97. What is the ratio of the Area (in %) of World in 1989 to that in 1993?
Make the answer very short. 1.07. What is the ratio of the Area (in %) of Romania in 1989 to that in 1993?
Offer a terse response. 0.99. What is the ratio of the Area (in %) in Least developed countries in 1989 to that in 1994?
Offer a terse response. 0.97. What is the ratio of the Area (in %) in World in 1989 to that in 1994?
Provide a succinct answer. 1.04. What is the ratio of the Area (in %) of Romania in 1989 to that in 1994?
Your answer should be very brief. 1.01. What is the ratio of the Area (in %) in Least developed countries in 1990 to that in 1991?
Give a very brief answer. 0.99. What is the ratio of the Area (in %) in World in 1990 to that in 1991?
Make the answer very short. 0.99. What is the ratio of the Area (in %) in Hong Kong in 1990 to that in 1991?
Your answer should be compact. 1. What is the ratio of the Area (in %) of Romania in 1990 to that in 1991?
Keep it short and to the point. 0.99. What is the ratio of the Area (in %) in Least developed countries in 1990 to that in 1992?
Offer a terse response. 0.99. What is the ratio of the Area (in %) of World in 1990 to that in 1992?
Make the answer very short. 1.12. What is the ratio of the Area (in %) of Romania in 1990 to that in 1992?
Provide a succinct answer. 0.98. What is the ratio of the Area (in %) of Least developed countries in 1990 to that in 1993?
Your answer should be compact. 0.99. What is the ratio of the Area (in %) of World in 1990 to that in 1993?
Provide a succinct answer. 1.09. What is the ratio of the Area (in %) in Romania in 1990 to that in 1993?
Give a very brief answer. 0.99. What is the ratio of the Area (in %) of Least developed countries in 1990 to that in 1994?
Your response must be concise. 0.99. What is the ratio of the Area (in %) in World in 1990 to that in 1994?
Keep it short and to the point. 1.07. What is the ratio of the Area (in %) in Romania in 1990 to that in 1994?
Keep it short and to the point. 1.01. What is the ratio of the Area (in %) of Least developed countries in 1991 to that in 1992?
Offer a terse response. 1. What is the ratio of the Area (in %) of World in 1991 to that in 1992?
Offer a terse response. 1.13. What is the ratio of the Area (in %) in Romania in 1991 to that in 1992?
Give a very brief answer. 0.99. What is the ratio of the Area (in %) of Least developed countries in 1991 to that in 1993?
Offer a terse response. 1. What is the ratio of the Area (in %) of World in 1991 to that in 1993?
Your answer should be very brief. 1.1. What is the ratio of the Area (in %) in Hong Kong in 1991 to that in 1993?
Your response must be concise. 1. What is the ratio of the Area (in %) in World in 1991 to that in 1994?
Your answer should be compact. 1.08. What is the ratio of the Area (in %) in Hong Kong in 1991 to that in 1994?
Provide a short and direct response. 1. What is the ratio of the Area (in %) of Romania in 1991 to that in 1994?
Offer a very short reply. 1.02. What is the ratio of the Area (in %) in Least developed countries in 1992 to that in 1993?
Ensure brevity in your answer.  1.01. What is the ratio of the Area (in %) in World in 1992 to that in 1993?
Offer a terse response. 0.97. What is the ratio of the Area (in %) of Hong Kong in 1992 to that in 1993?
Your response must be concise. 1. What is the ratio of the Area (in %) of Least developed countries in 1992 to that in 1994?
Your answer should be compact. 1. What is the ratio of the Area (in %) of World in 1992 to that in 1994?
Your answer should be very brief. 0.95. What is the ratio of the Area (in %) in Hong Kong in 1992 to that in 1994?
Offer a terse response. 1. What is the ratio of the Area (in %) in Romania in 1992 to that in 1994?
Your response must be concise. 1.03. What is the ratio of the Area (in %) of World in 1993 to that in 1994?
Your response must be concise. 0.98. What is the ratio of the Area (in %) in Hong Kong in 1993 to that in 1994?
Make the answer very short. 1. What is the ratio of the Area (in %) in Romania in 1993 to that in 1994?
Your response must be concise. 1.02. What is the difference between the highest and the second highest Area (in %) of Least developed countries?
Offer a terse response. 0. What is the difference between the highest and the second highest Area (in %) in World?
Offer a terse response. 0.01. What is the difference between the highest and the second highest Area (in %) in Romania?
Offer a terse response. 0. What is the difference between the highest and the lowest Area (in %) of Least developed countries?
Give a very brief answer. 0.03. What is the difference between the highest and the lowest Area (in %) in World?
Your answer should be compact. 0.13. What is the difference between the highest and the lowest Area (in %) of Romania?
Offer a very short reply. 0.07. 